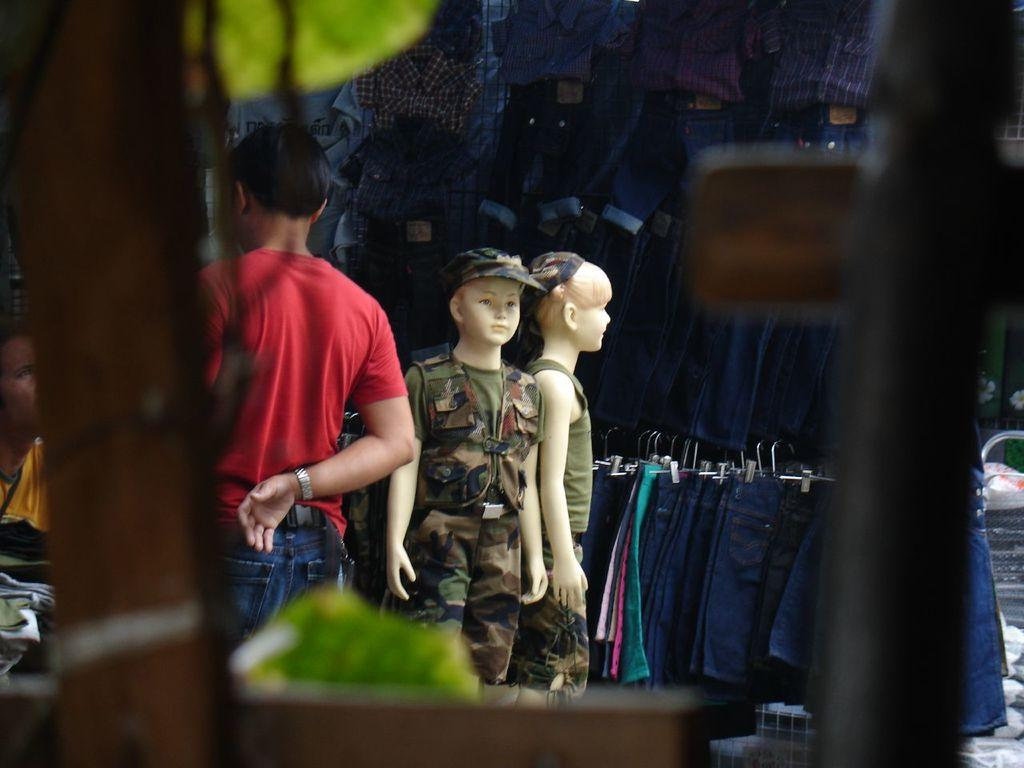How many mannequins are in the image? There are two mannequins in the image. What are the mannequins wearing? The mannequins are wearing military dress. Can you describe the people visible in the image? There are people visible in the image, but their specific characteristics are not mentioned in the facts. What color dresses are present in the image? There are blue color dresses present in the image. What type of coil is being used to solve the riddle in the image? There is no coil or riddle present in the image. How much salt is visible on the mannequins in the image? There is no salt visible on the mannequins in the image. 